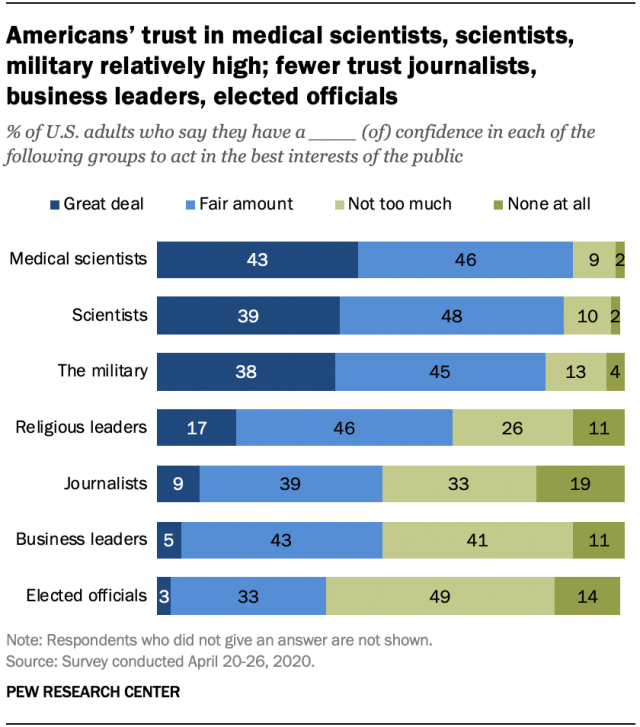Specify some key components in this picture. The lowest value of the navy blue bar is 3. The sum of the median and the largest value of the navy blue bar is 60. 